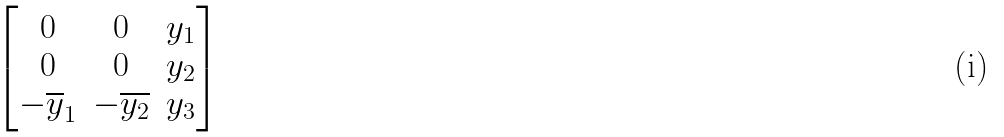Convert formula to latex. <formula><loc_0><loc_0><loc_500><loc_500>\begin{bmatrix} 0 & 0 & y _ { 1 } \\ 0 & 0 & y _ { 2 } \\ - \overline { y } _ { 1 } & - \overline { y _ { 2 } } & y _ { 3 } \end{bmatrix}</formula> 